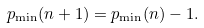Convert formula to latex. <formula><loc_0><loc_0><loc_500><loc_500>p _ { \min } ( n + 1 ) = p _ { \min } ( n ) - 1 .</formula> 